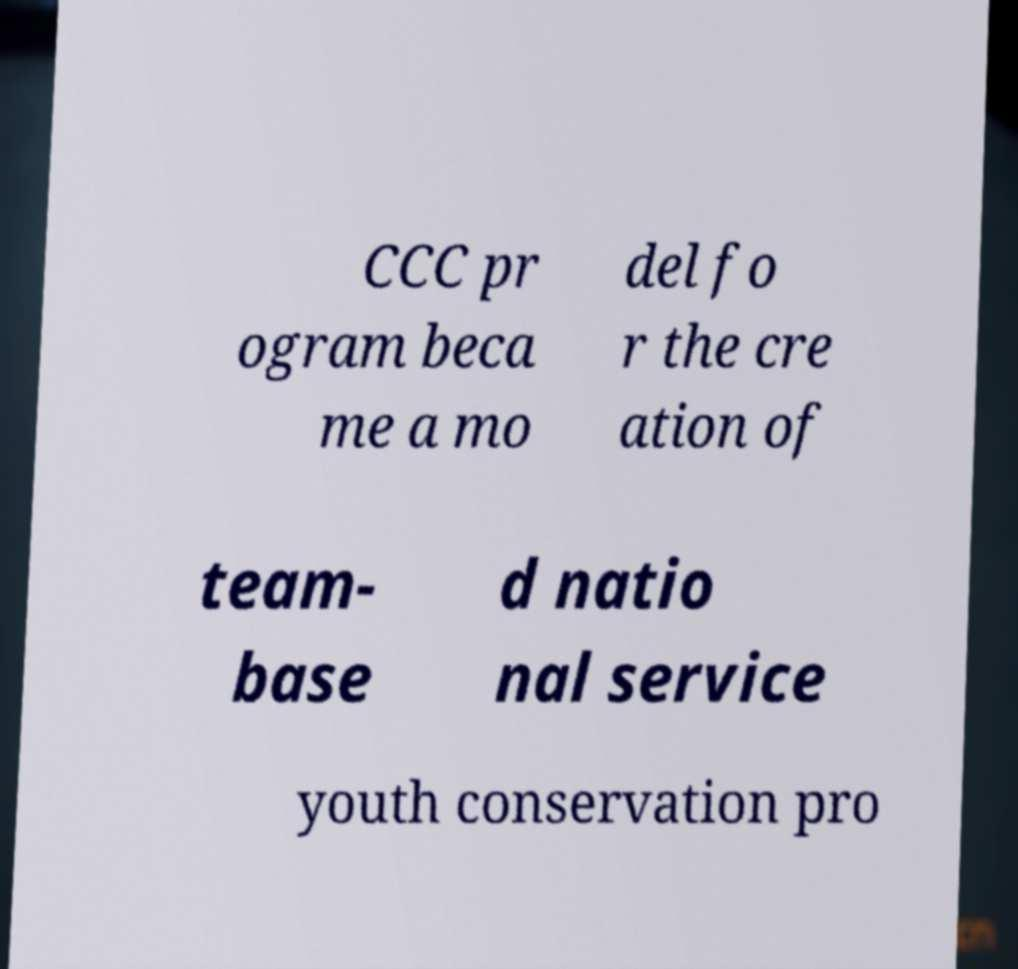Can you read and provide the text displayed in the image?This photo seems to have some interesting text. Can you extract and type it out for me? CCC pr ogram beca me a mo del fo r the cre ation of team- base d natio nal service youth conservation pro 